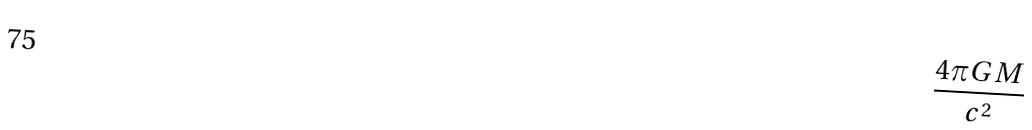Convert formula to latex. <formula><loc_0><loc_0><loc_500><loc_500>\frac { 4 \pi G M } { c ^ { 2 } }</formula> 